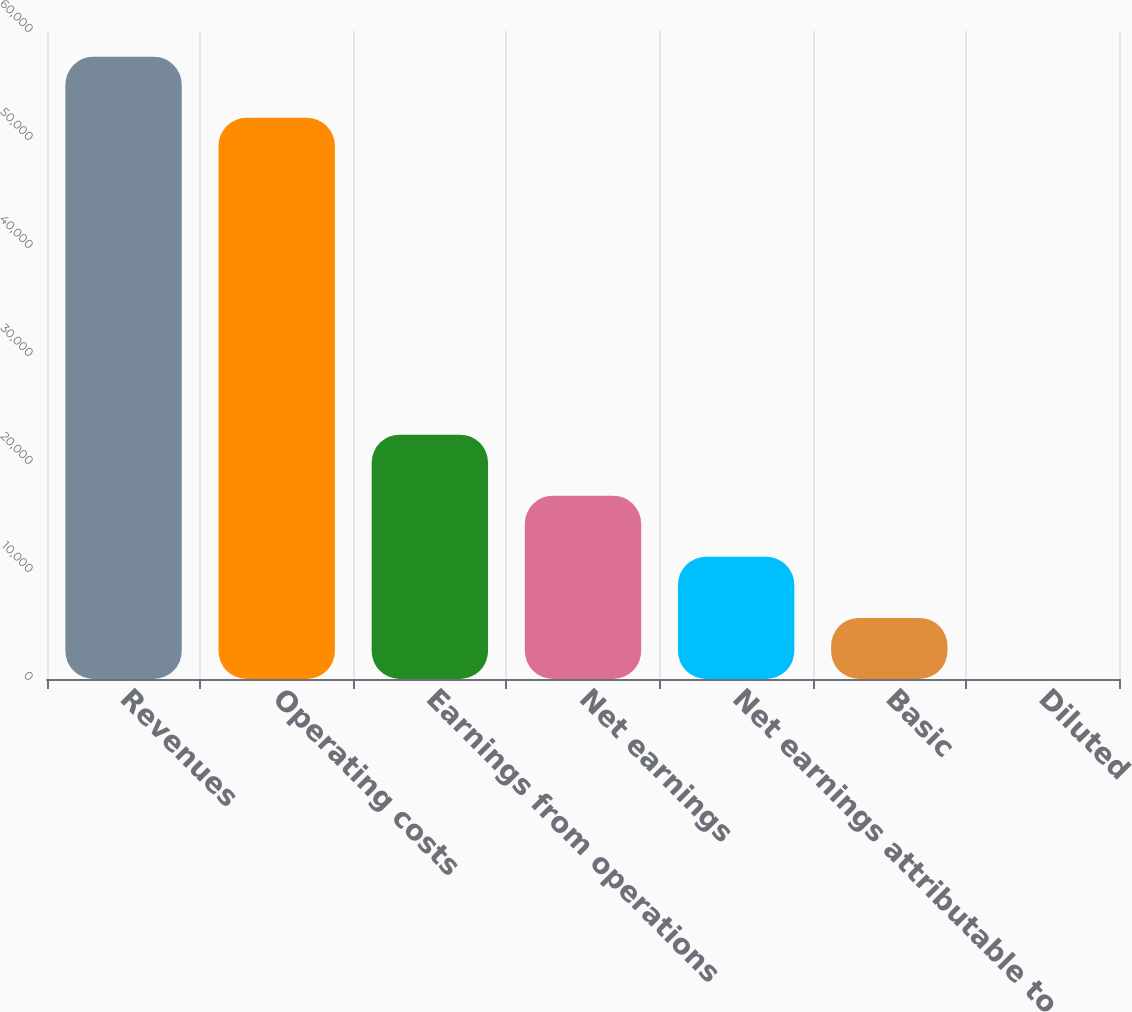<chart> <loc_0><loc_0><loc_500><loc_500><bar_chart><fcel>Revenues<fcel>Operating costs<fcel>Earnings from operations<fcel>Net earnings<fcel>Net earnings attributable to<fcel>Basic<fcel>Diluted<nl><fcel>57621.3<fcel>51966<fcel>22624.4<fcel>16969.1<fcel>11313.8<fcel>5658.52<fcel>3.24<nl></chart> 